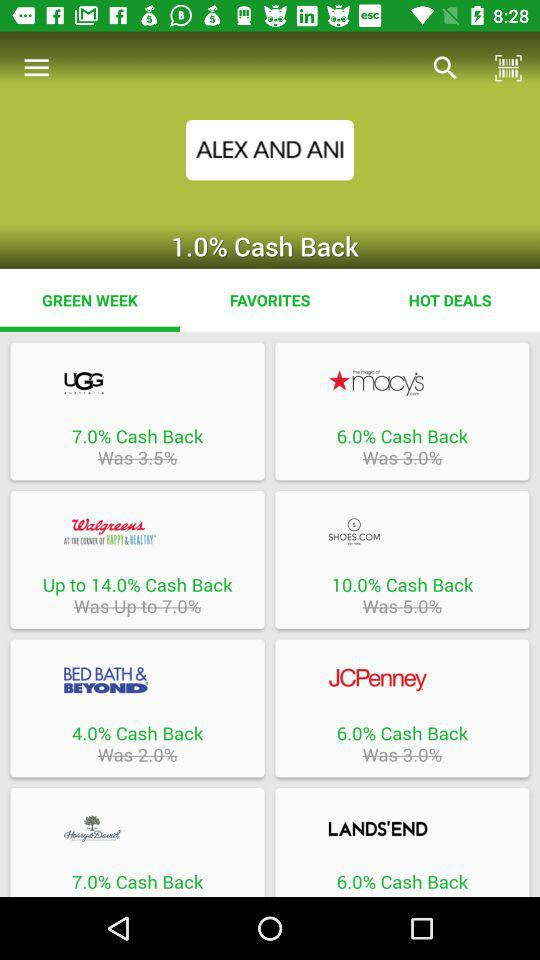How many percent cash back is offered on Walgreens AT THE CONCEPT OF HAPPY HEALTHTM?
Answer the question using a single word or phrase. Up to 14.0% 